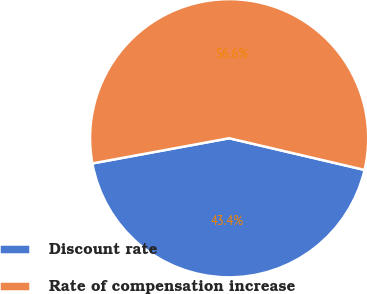Convert chart. <chart><loc_0><loc_0><loc_500><loc_500><pie_chart><fcel>Discount rate<fcel>Rate of compensation increase<nl><fcel>43.44%<fcel>56.56%<nl></chart> 